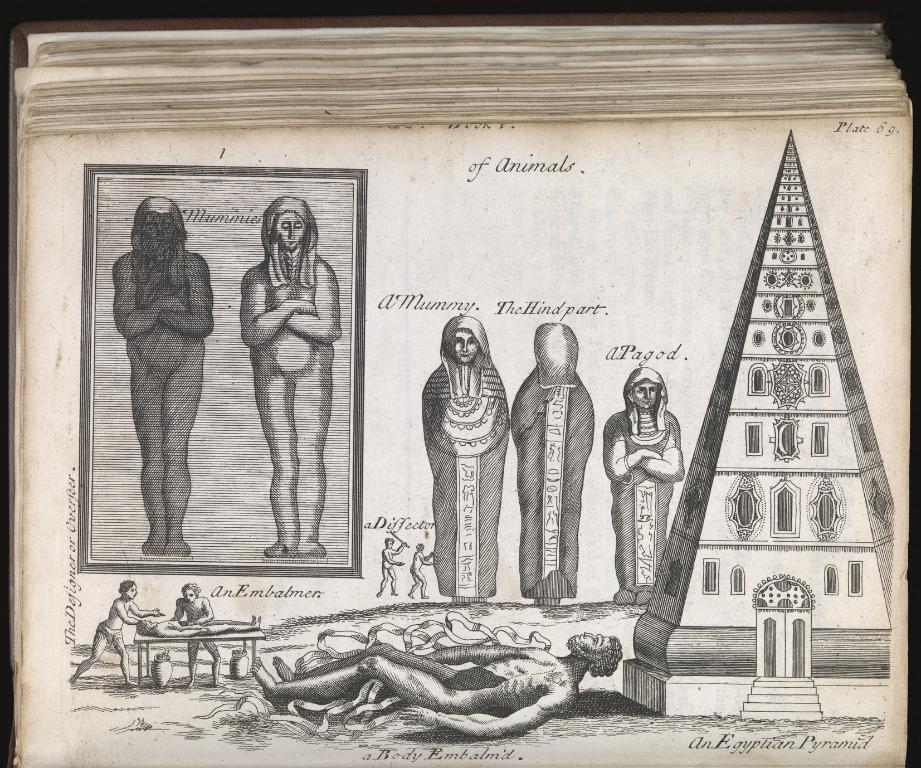What is present in the image related to reading or writing? There is a book and a paper in the image. What can be found on the paper in the image? The paper contains drawings of mummies and a drawing of a building. What type of celery is being used to draw the mummies on the paper? There is no celery present in the image, and celery is not used for drawing. 